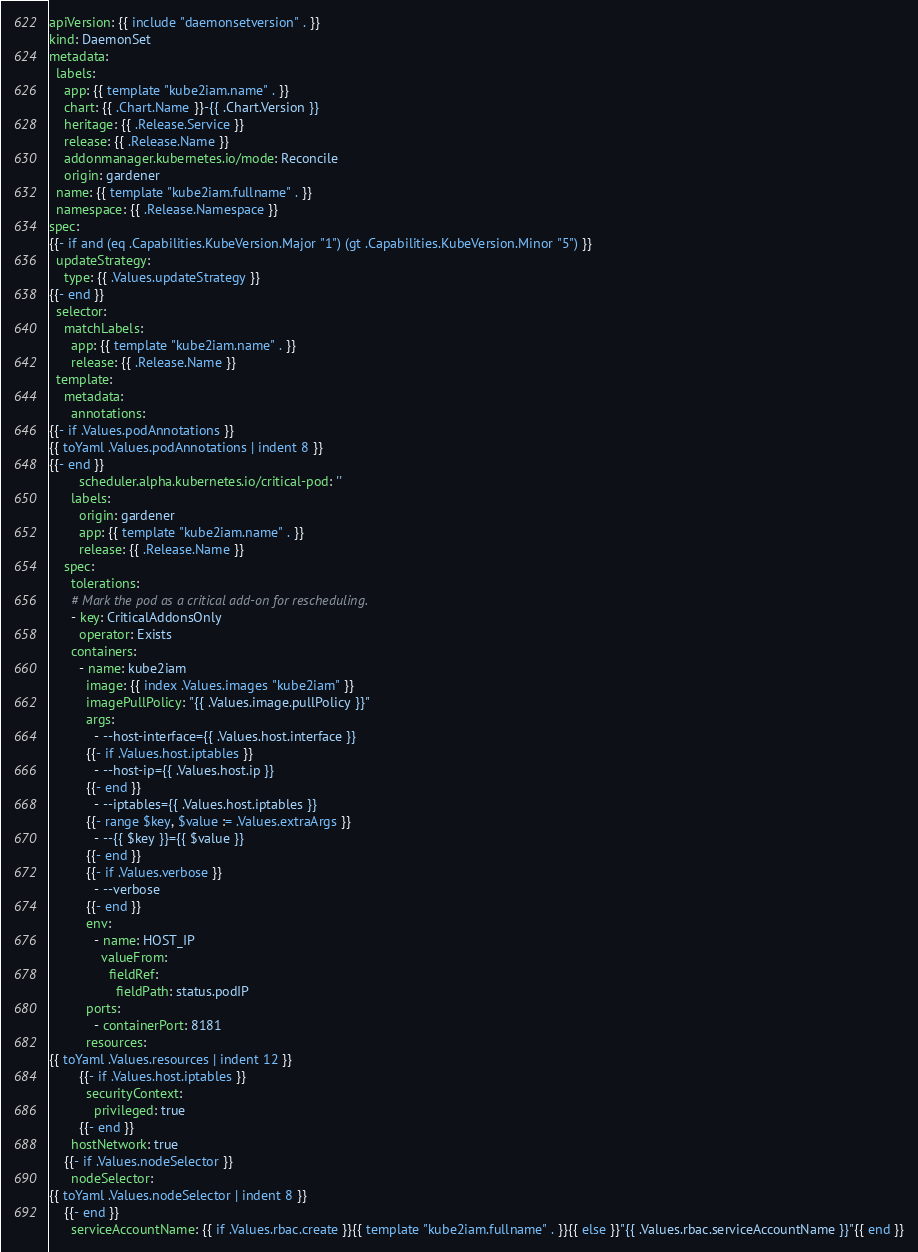Convert code to text. <code><loc_0><loc_0><loc_500><loc_500><_YAML_>apiVersion: {{ include "daemonsetversion" . }}
kind: DaemonSet
metadata:
  labels:
    app: {{ template "kube2iam.name" . }}
    chart: {{ .Chart.Name }}-{{ .Chart.Version }}
    heritage: {{ .Release.Service }}
    release: {{ .Release.Name }}
    addonmanager.kubernetes.io/mode: Reconcile
    origin: gardener
  name: {{ template "kube2iam.fullname" . }}
  namespace: {{ .Release.Namespace }}
spec:
{{- if and (eq .Capabilities.KubeVersion.Major "1") (gt .Capabilities.KubeVersion.Minor "5") }}
  updateStrategy:
    type: {{ .Values.updateStrategy }}
{{- end }}
  selector:
    matchLabels:
      app: {{ template "kube2iam.name" . }}
      release: {{ .Release.Name }}
  template:
    metadata:
      annotations:
{{- if .Values.podAnnotations }}
{{ toYaml .Values.podAnnotations | indent 8 }}
{{- end }}
        scheduler.alpha.kubernetes.io/critical-pod: ''
      labels:
        origin: gardener
        app: {{ template "kube2iam.name" . }}
        release: {{ .Release.Name }}
    spec:
      tolerations:
      # Mark the pod as a critical add-on for rescheduling.
      - key: CriticalAddonsOnly
        operator: Exists
      containers:
        - name: kube2iam
          image: {{ index .Values.images "kube2iam" }}
          imagePullPolicy: "{{ .Values.image.pullPolicy }}"
          args:
            - --host-interface={{ .Values.host.interface }}
          {{- if .Values.host.iptables }}
            - --host-ip={{ .Values.host.ip }}
          {{- end }}
            - --iptables={{ .Values.host.iptables }}
          {{- range $key, $value := .Values.extraArgs }}
            - --{{ $key }}={{ $value }}
          {{- end }}
          {{- if .Values.verbose }}
            - --verbose
          {{- end }}
          env:
            - name: HOST_IP
              valueFrom:
                fieldRef:
                  fieldPath: status.podIP
          ports:
            - containerPort: 8181
          resources:
{{ toYaml .Values.resources | indent 12 }}
        {{- if .Values.host.iptables }}
          securityContext:
            privileged: true
        {{- end }}
      hostNetwork: true
    {{- if .Values.nodeSelector }}
      nodeSelector:
{{ toYaml .Values.nodeSelector | indent 8 }}
    {{- end }}
      serviceAccountName: {{ if .Values.rbac.create }}{{ template "kube2iam.fullname" . }}{{ else }}"{{ .Values.rbac.serviceAccountName }}"{{ end }}
</code> 